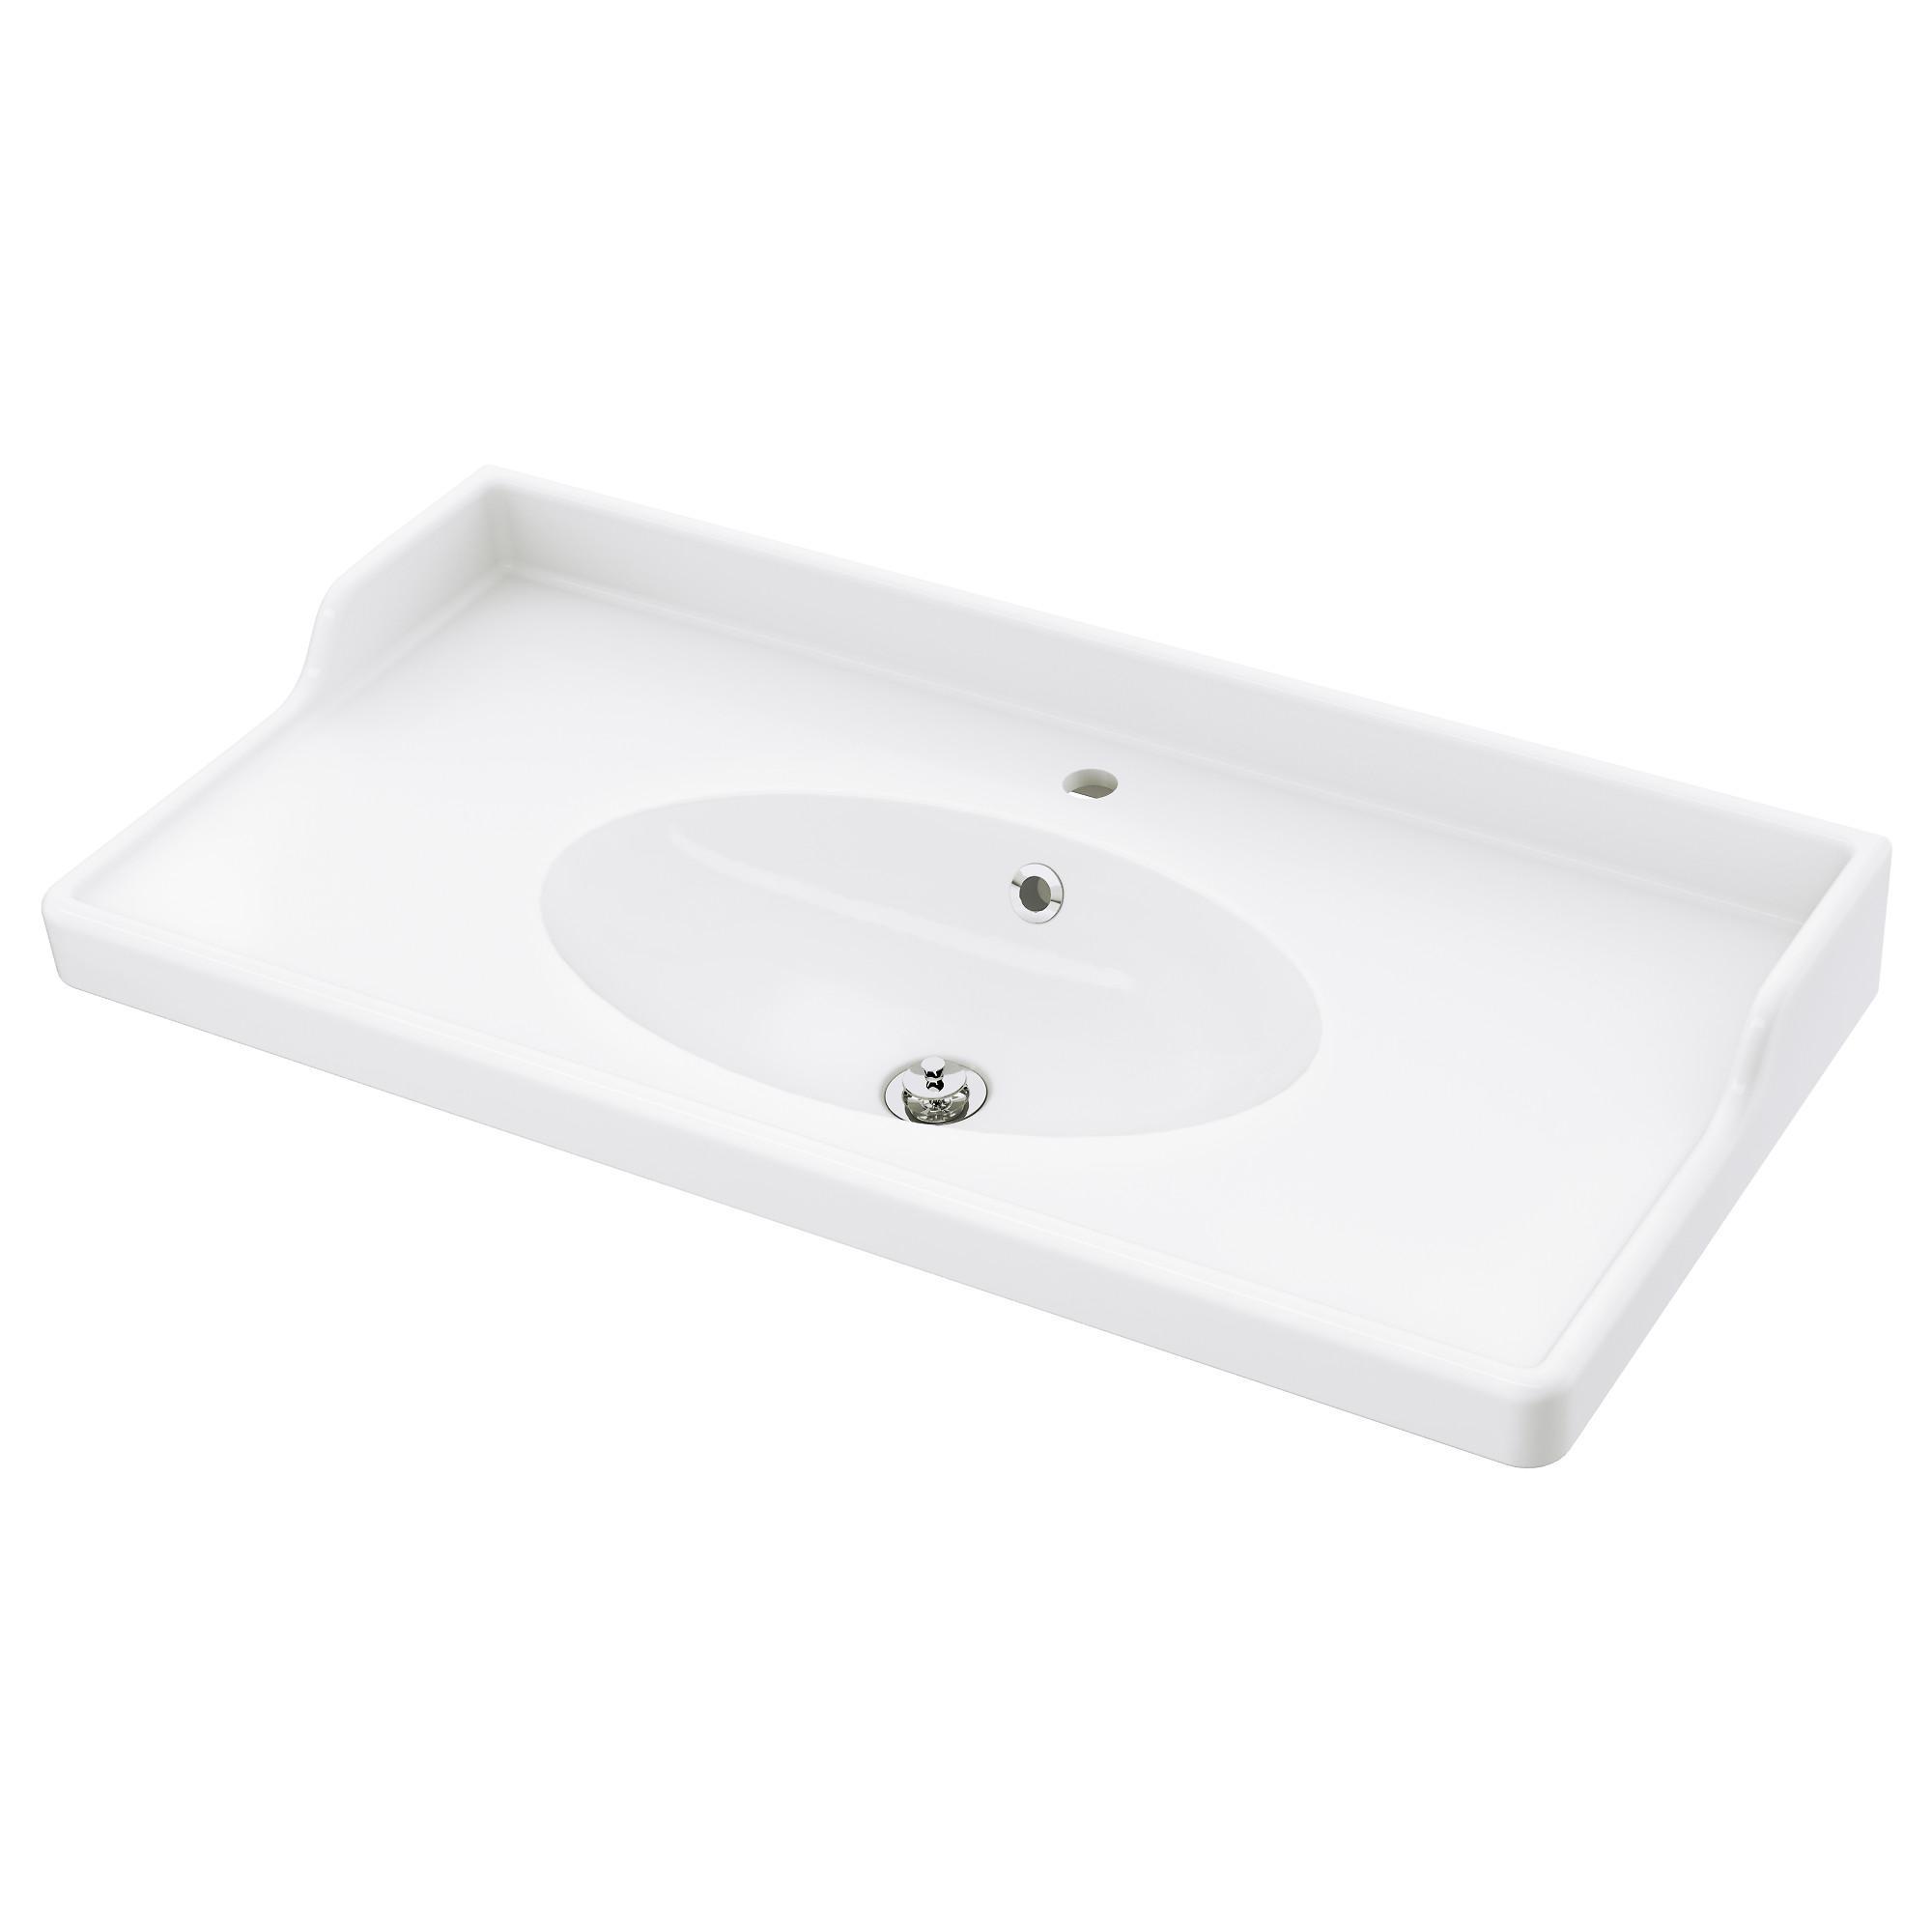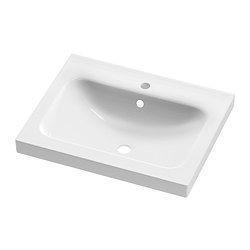The first image is the image on the left, the second image is the image on the right. Considering the images on both sides, is "At least one sink is more oblong than rectangular, and no sink has a faucet or spout installed." valid? Answer yes or no. Yes. The first image is the image on the left, the second image is the image on the right. Considering the images on both sides, is "There are two wash basins facing the same direction." valid? Answer yes or no. Yes. 